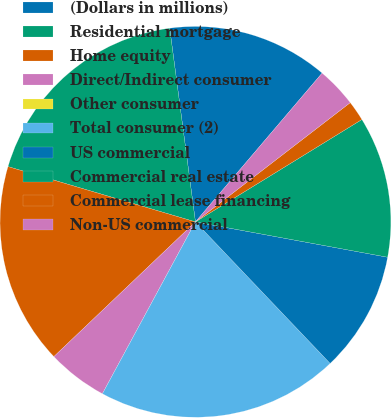<chart> <loc_0><loc_0><loc_500><loc_500><pie_chart><fcel>(Dollars in millions)<fcel>Residential mortgage<fcel>Home equity<fcel>Direct/Indirect consumer<fcel>Other consumer<fcel>Total consumer (2)<fcel>US commercial<fcel>Commercial real estate<fcel>Commercial lease financing<fcel>Non-US commercial<nl><fcel>13.33%<fcel>18.33%<fcel>16.67%<fcel>5.0%<fcel>0.0%<fcel>20.0%<fcel>10.0%<fcel>11.67%<fcel>1.67%<fcel>3.33%<nl></chart> 